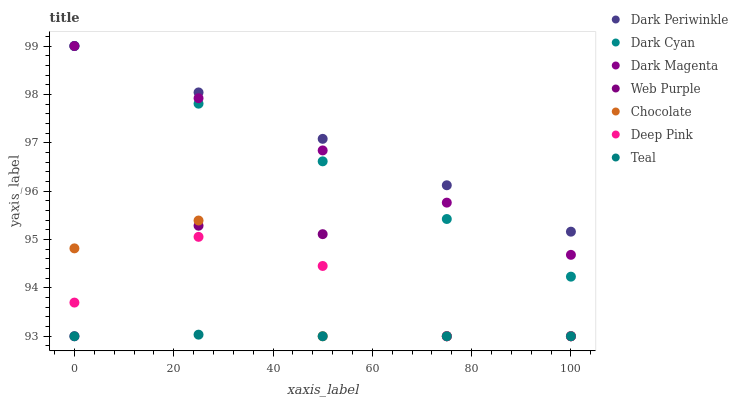Does Teal have the minimum area under the curve?
Answer yes or no. Yes. Does Dark Periwinkle have the maximum area under the curve?
Answer yes or no. Yes. Does Dark Magenta have the minimum area under the curve?
Answer yes or no. No. Does Dark Magenta have the maximum area under the curve?
Answer yes or no. No. Is Dark Periwinkle the smoothest?
Answer yes or no. Yes. Is Web Purple the roughest?
Answer yes or no. Yes. Is Dark Magenta the smoothest?
Answer yes or no. No. Is Dark Magenta the roughest?
Answer yes or no. No. Does Deep Pink have the lowest value?
Answer yes or no. Yes. Does Dark Magenta have the lowest value?
Answer yes or no. No. Does Dark Periwinkle have the highest value?
Answer yes or no. Yes. Does Chocolate have the highest value?
Answer yes or no. No. Is Deep Pink less than Dark Cyan?
Answer yes or no. Yes. Is Dark Cyan greater than Web Purple?
Answer yes or no. Yes. Does Dark Cyan intersect Dark Periwinkle?
Answer yes or no. Yes. Is Dark Cyan less than Dark Periwinkle?
Answer yes or no. No. Is Dark Cyan greater than Dark Periwinkle?
Answer yes or no. No. Does Deep Pink intersect Dark Cyan?
Answer yes or no. No. 